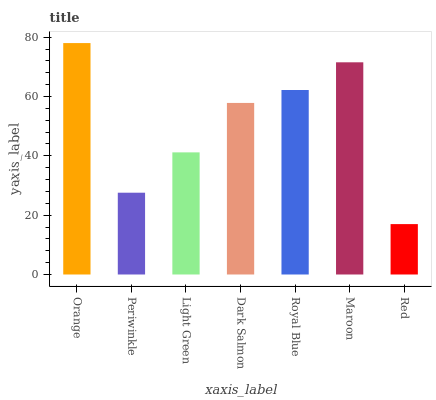Is Red the minimum?
Answer yes or no. Yes. Is Orange the maximum?
Answer yes or no. Yes. Is Periwinkle the minimum?
Answer yes or no. No. Is Periwinkle the maximum?
Answer yes or no. No. Is Orange greater than Periwinkle?
Answer yes or no. Yes. Is Periwinkle less than Orange?
Answer yes or no. Yes. Is Periwinkle greater than Orange?
Answer yes or no. No. Is Orange less than Periwinkle?
Answer yes or no. No. Is Dark Salmon the high median?
Answer yes or no. Yes. Is Dark Salmon the low median?
Answer yes or no. Yes. Is Orange the high median?
Answer yes or no. No. Is Periwinkle the low median?
Answer yes or no. No. 